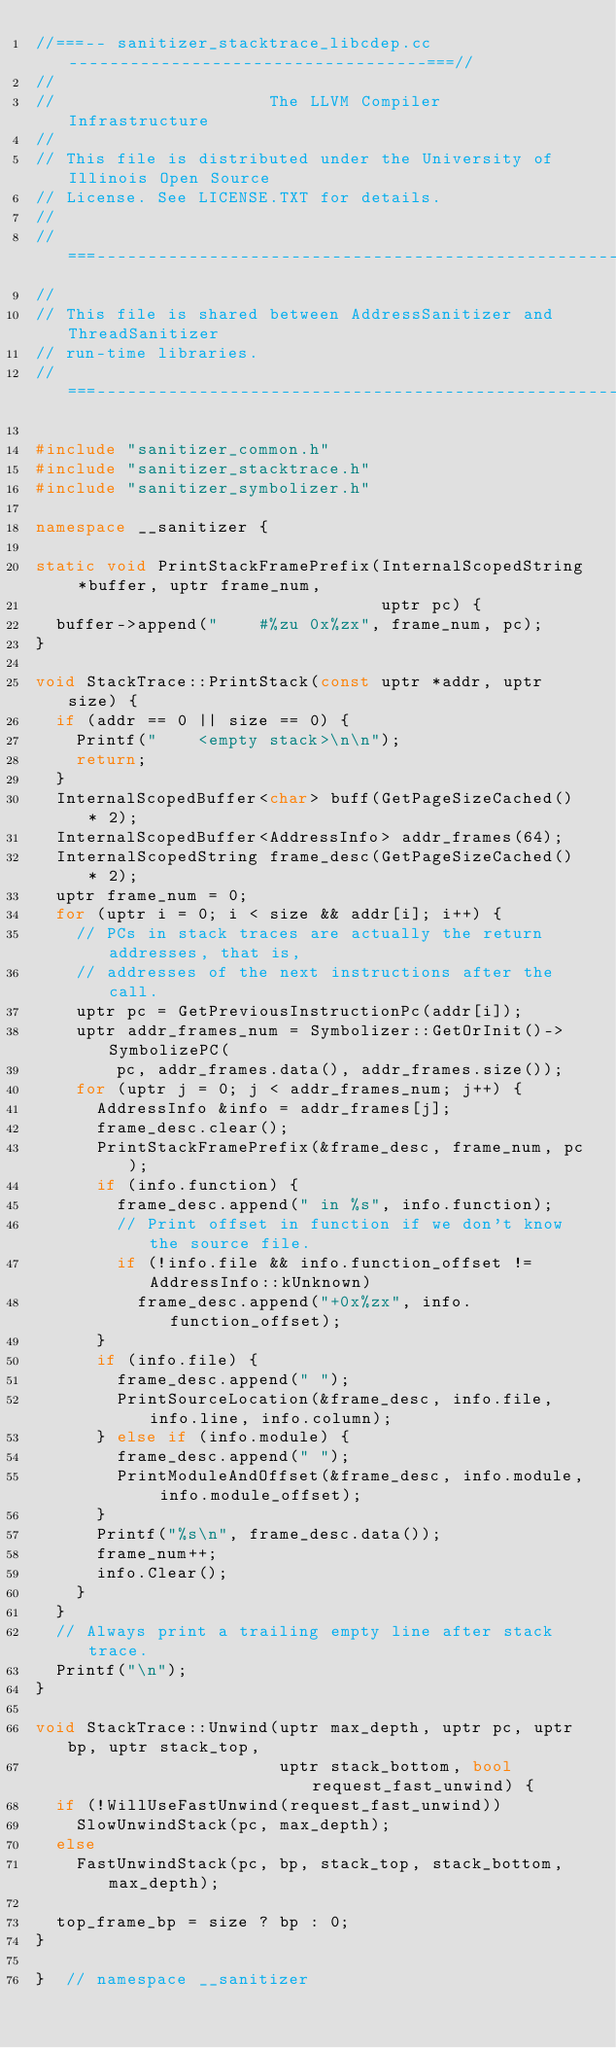<code> <loc_0><loc_0><loc_500><loc_500><_C++_>//===-- sanitizer_stacktrace_libcdep.cc -----------------------------------===//
//
//                     The LLVM Compiler Infrastructure
//
// This file is distributed under the University of Illinois Open Source
// License. See LICENSE.TXT for details.
//
//===----------------------------------------------------------------------===//
//
// This file is shared between AddressSanitizer and ThreadSanitizer
// run-time libraries.
//===----------------------------------------------------------------------===//

#include "sanitizer_common.h"
#include "sanitizer_stacktrace.h"
#include "sanitizer_symbolizer.h"

namespace __sanitizer {

static void PrintStackFramePrefix(InternalScopedString *buffer, uptr frame_num,
                                  uptr pc) {
  buffer->append("    #%zu 0x%zx", frame_num, pc);
}

void StackTrace::PrintStack(const uptr *addr, uptr size) {
  if (addr == 0 || size == 0) {
    Printf("    <empty stack>\n\n");
    return;
  }
  InternalScopedBuffer<char> buff(GetPageSizeCached() * 2);
  InternalScopedBuffer<AddressInfo> addr_frames(64);
  InternalScopedString frame_desc(GetPageSizeCached() * 2);
  uptr frame_num = 0;
  for (uptr i = 0; i < size && addr[i]; i++) {
    // PCs in stack traces are actually the return addresses, that is,
    // addresses of the next instructions after the call.
    uptr pc = GetPreviousInstructionPc(addr[i]);
    uptr addr_frames_num = Symbolizer::GetOrInit()->SymbolizePC(
        pc, addr_frames.data(), addr_frames.size());
    for (uptr j = 0; j < addr_frames_num; j++) {
      AddressInfo &info = addr_frames[j];
      frame_desc.clear();
      PrintStackFramePrefix(&frame_desc, frame_num, pc);
      if (info.function) {
        frame_desc.append(" in %s", info.function);
        // Print offset in function if we don't know the source file.
        if (!info.file && info.function_offset != AddressInfo::kUnknown)
          frame_desc.append("+0x%zx", info.function_offset);
      }
      if (info.file) {
        frame_desc.append(" ");
        PrintSourceLocation(&frame_desc, info.file, info.line, info.column);
      } else if (info.module) {
        frame_desc.append(" ");
        PrintModuleAndOffset(&frame_desc, info.module, info.module_offset);
      }
      Printf("%s\n", frame_desc.data());
      frame_num++;
      info.Clear();
    }
  }
  // Always print a trailing empty line after stack trace.
  Printf("\n");
}

void StackTrace::Unwind(uptr max_depth, uptr pc, uptr bp, uptr stack_top,
                        uptr stack_bottom, bool request_fast_unwind) {
  if (!WillUseFastUnwind(request_fast_unwind))
    SlowUnwindStack(pc, max_depth);
  else
    FastUnwindStack(pc, bp, stack_top, stack_bottom, max_depth);

  top_frame_bp = size ? bp : 0;
}

}  // namespace __sanitizer
</code> 